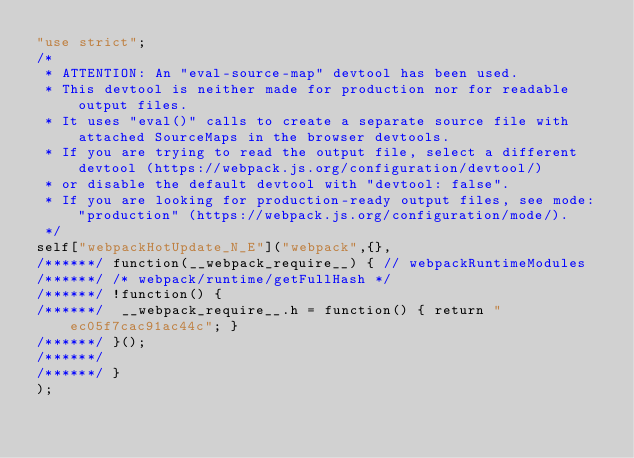<code> <loc_0><loc_0><loc_500><loc_500><_JavaScript_>"use strict";
/*
 * ATTENTION: An "eval-source-map" devtool has been used.
 * This devtool is neither made for production nor for readable output files.
 * It uses "eval()" calls to create a separate source file with attached SourceMaps in the browser devtools.
 * If you are trying to read the output file, select a different devtool (https://webpack.js.org/configuration/devtool/)
 * or disable the default devtool with "devtool: false".
 * If you are looking for production-ready output files, see mode: "production" (https://webpack.js.org/configuration/mode/).
 */
self["webpackHotUpdate_N_E"]("webpack",{},
/******/ function(__webpack_require__) { // webpackRuntimeModules
/******/ /* webpack/runtime/getFullHash */
/******/ !function() {
/******/ 	__webpack_require__.h = function() { return "ec05f7cac91ac44c"; }
/******/ }();
/******/ 
/******/ }
);</code> 